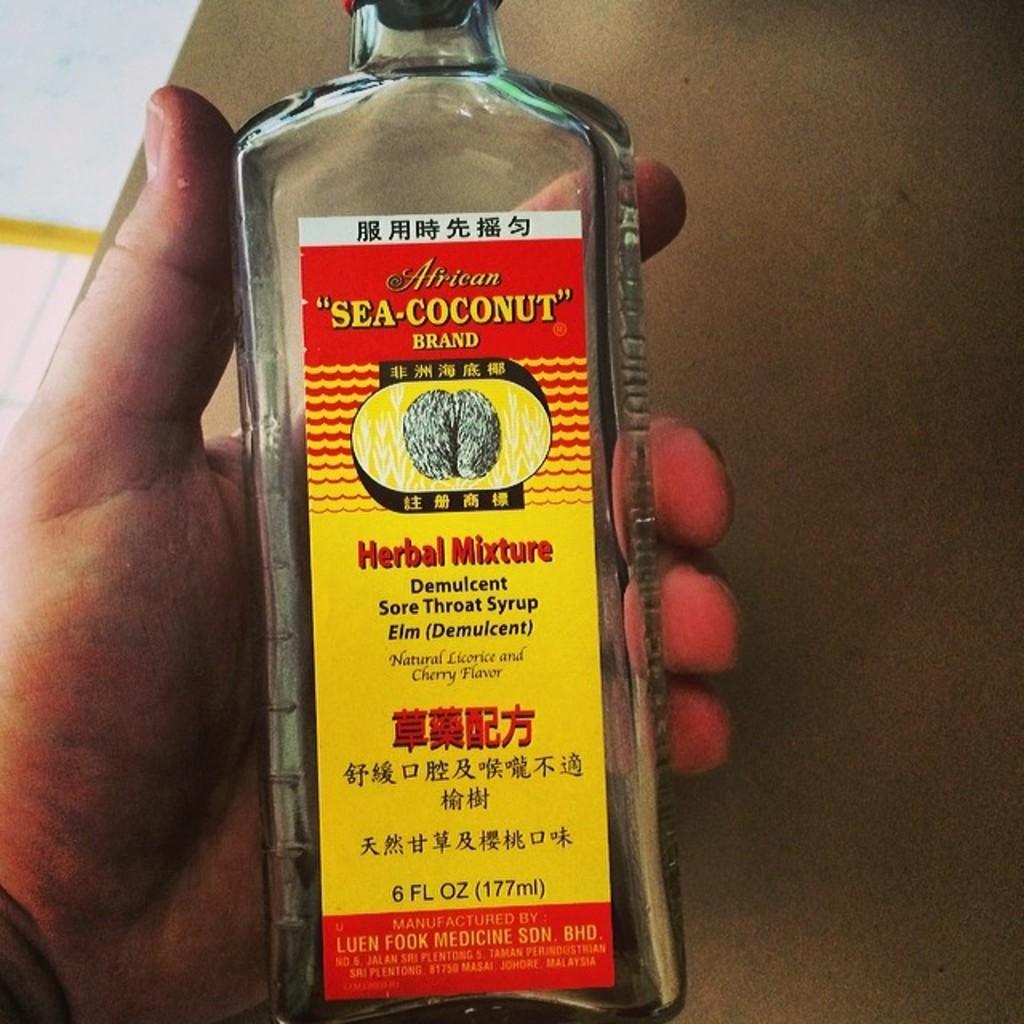What is written between the quotation marks, above the word brand and below the word african?
Your answer should be compact. Sea-coconut. What brand of mixture is this?
Give a very brief answer. Sea-coconut. 